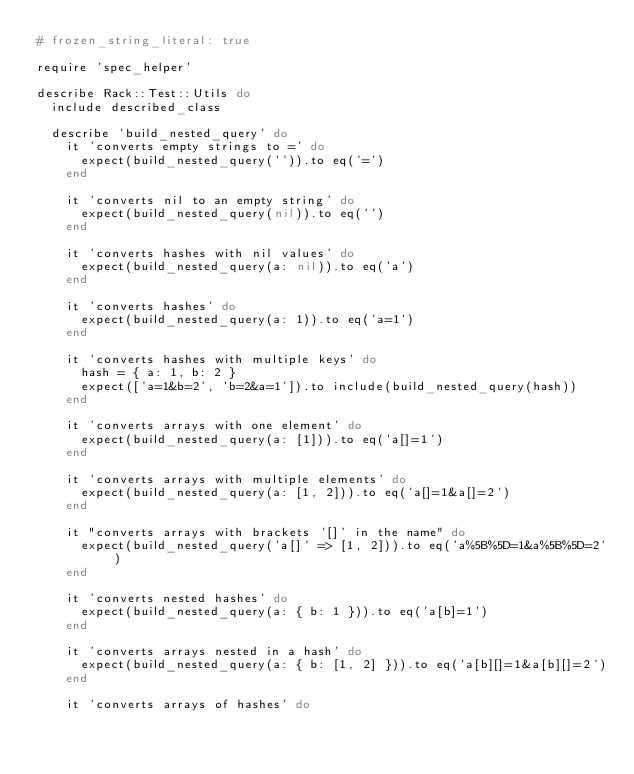<code> <loc_0><loc_0><loc_500><loc_500><_Ruby_># frozen_string_literal: true

require 'spec_helper'

describe Rack::Test::Utils do
  include described_class

  describe 'build_nested_query' do
    it 'converts empty strings to =' do
      expect(build_nested_query('')).to eq('=')
    end

    it 'converts nil to an empty string' do
      expect(build_nested_query(nil)).to eq('')
    end

    it 'converts hashes with nil values' do
      expect(build_nested_query(a: nil)).to eq('a')
    end

    it 'converts hashes' do
      expect(build_nested_query(a: 1)).to eq('a=1')
    end

    it 'converts hashes with multiple keys' do
      hash = { a: 1, b: 2 }
      expect(['a=1&b=2', 'b=2&a=1']).to include(build_nested_query(hash))
    end

    it 'converts arrays with one element' do
      expect(build_nested_query(a: [1])).to eq('a[]=1')
    end

    it 'converts arrays with multiple elements' do
      expect(build_nested_query(a: [1, 2])).to eq('a[]=1&a[]=2')
    end

    it "converts arrays with brackets '[]' in the name" do
      expect(build_nested_query('a[]' => [1, 2])).to eq('a%5B%5D=1&a%5B%5D=2')
    end

    it 'converts nested hashes' do
      expect(build_nested_query(a: { b: 1 })).to eq('a[b]=1')
    end

    it 'converts arrays nested in a hash' do
      expect(build_nested_query(a: { b: [1, 2] })).to eq('a[b][]=1&a[b][]=2')
    end

    it 'converts arrays of hashes' do</code> 